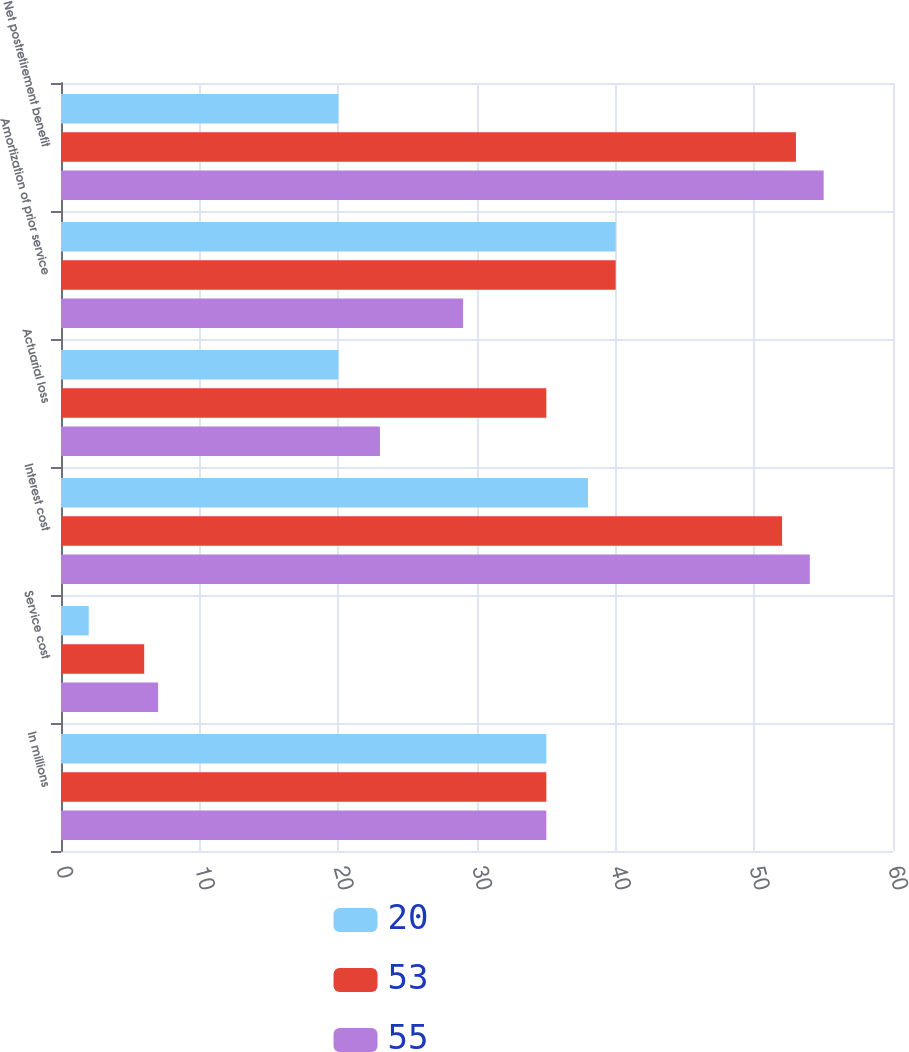Convert chart. <chart><loc_0><loc_0><loc_500><loc_500><stacked_bar_chart><ecel><fcel>In millions<fcel>Service cost<fcel>Interest cost<fcel>Actuarial loss<fcel>Amortization of prior service<fcel>Net postretirement benefit<nl><fcel>20<fcel>35<fcel>2<fcel>38<fcel>20<fcel>40<fcel>20<nl><fcel>53<fcel>35<fcel>6<fcel>52<fcel>35<fcel>40<fcel>53<nl><fcel>55<fcel>35<fcel>7<fcel>54<fcel>23<fcel>29<fcel>55<nl></chart> 